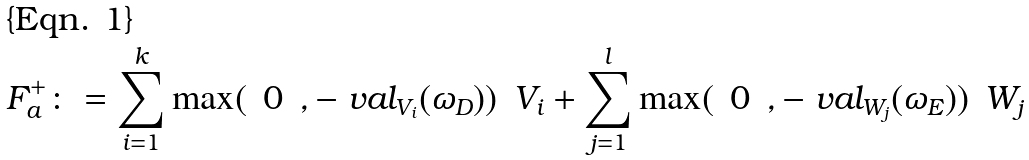Convert formula to latex. <formula><loc_0><loc_0><loc_500><loc_500>F _ { a } ^ { + } \colon = \sum _ { i = 1 } ^ { k } \max ( \ \, 0 \ \, , - \ v a l _ { V _ { i } } ( \omega _ { D } ) ) \ \, V _ { i } + \sum _ { j = 1 } ^ { l } \max ( \ \, 0 \ \, , - \ v a l _ { W _ { j } } ( \omega _ { E } ) ) \ \, W _ { j }</formula> 